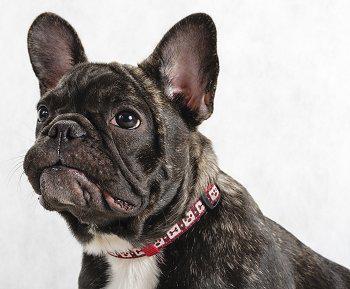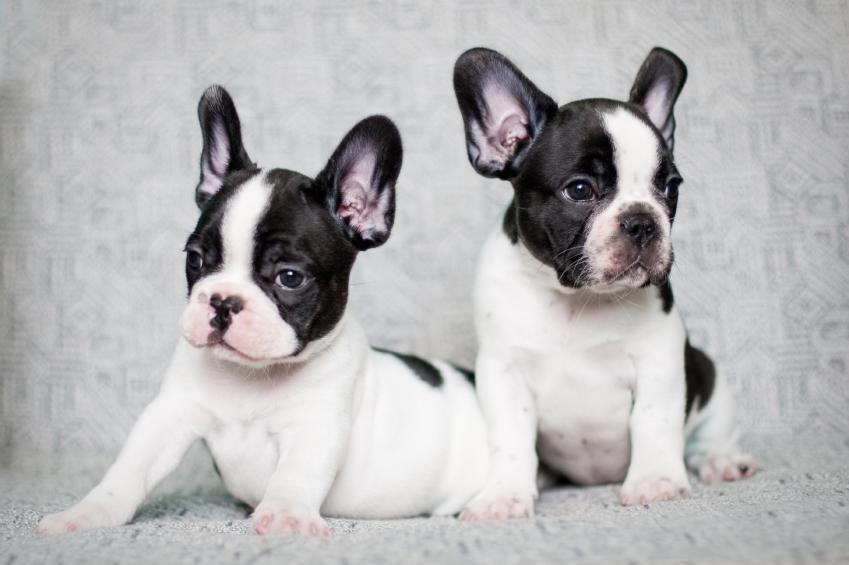The first image is the image on the left, the second image is the image on the right. Assess this claim about the two images: "There are exactly three dogs standing on all fours.". Correct or not? Answer yes or no. No. 